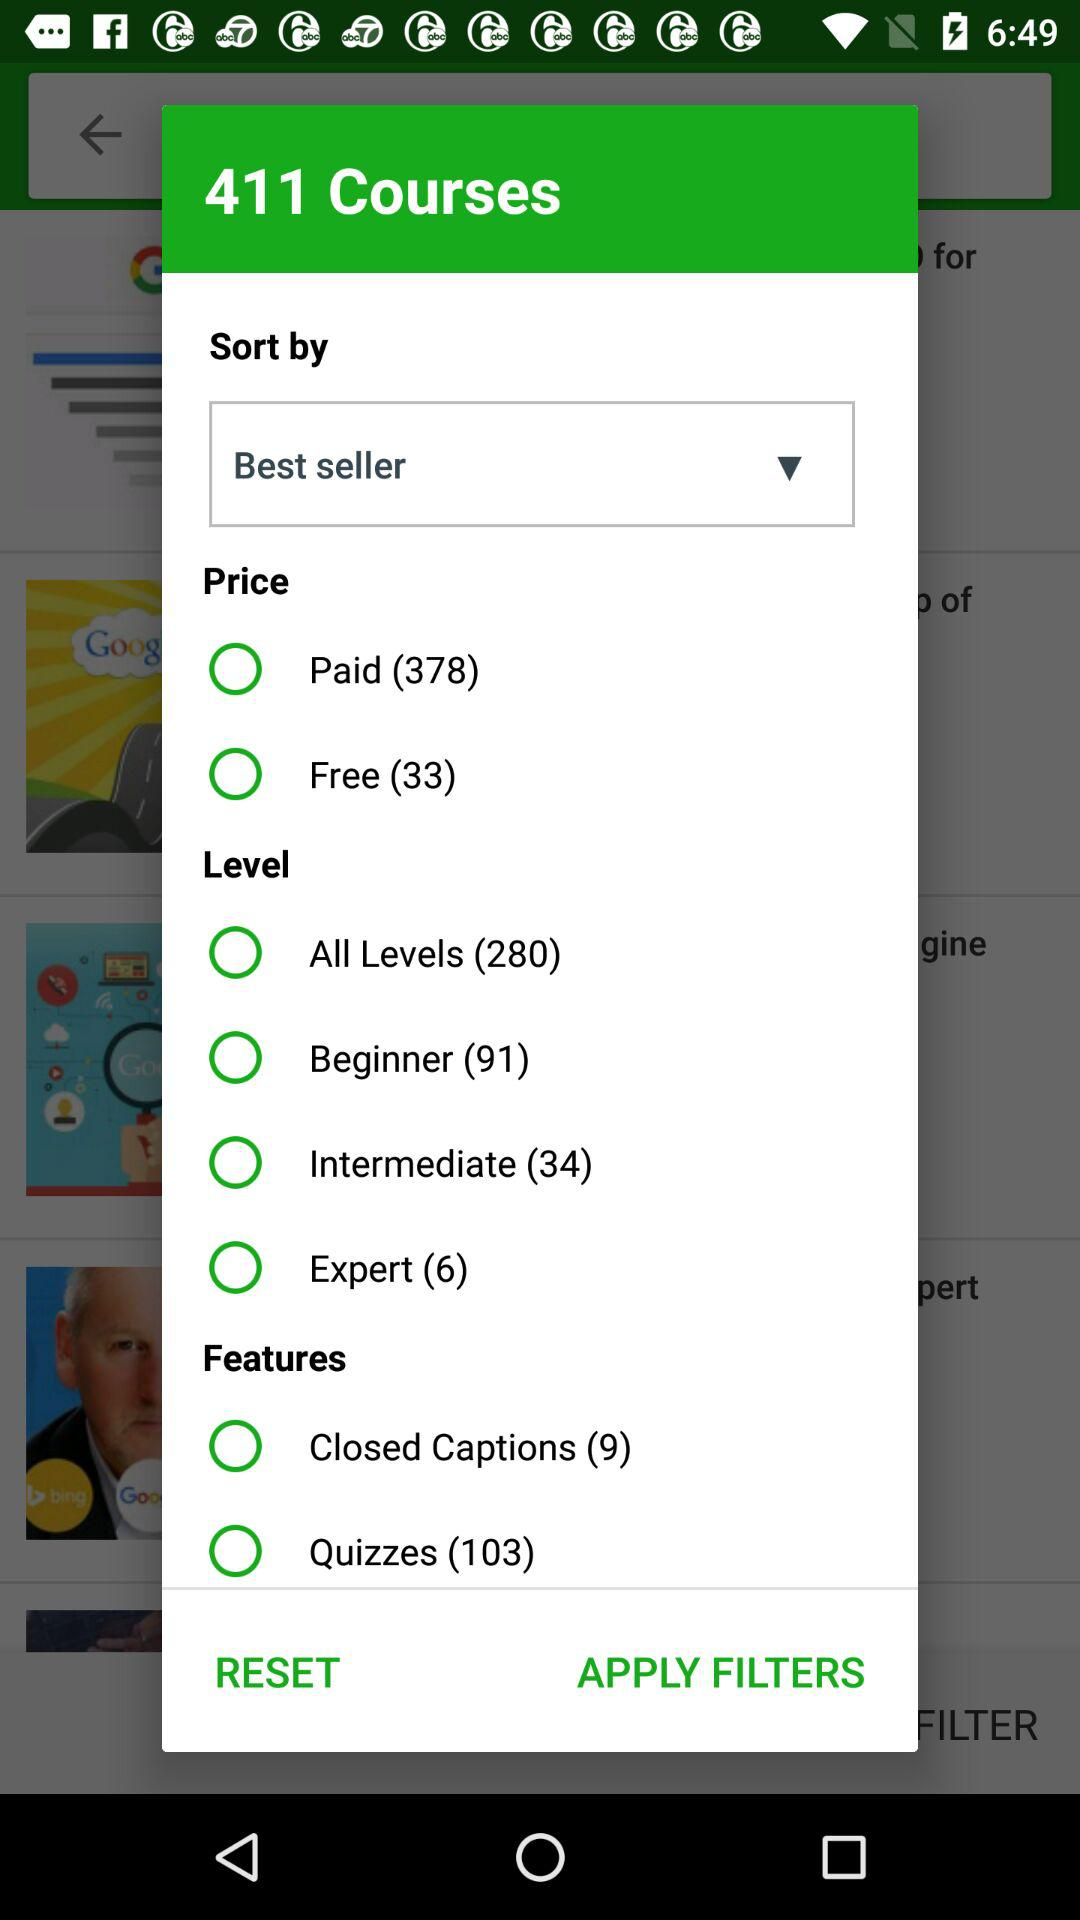What is the number of courses available at Intermediate level? The number of courses is 34. 